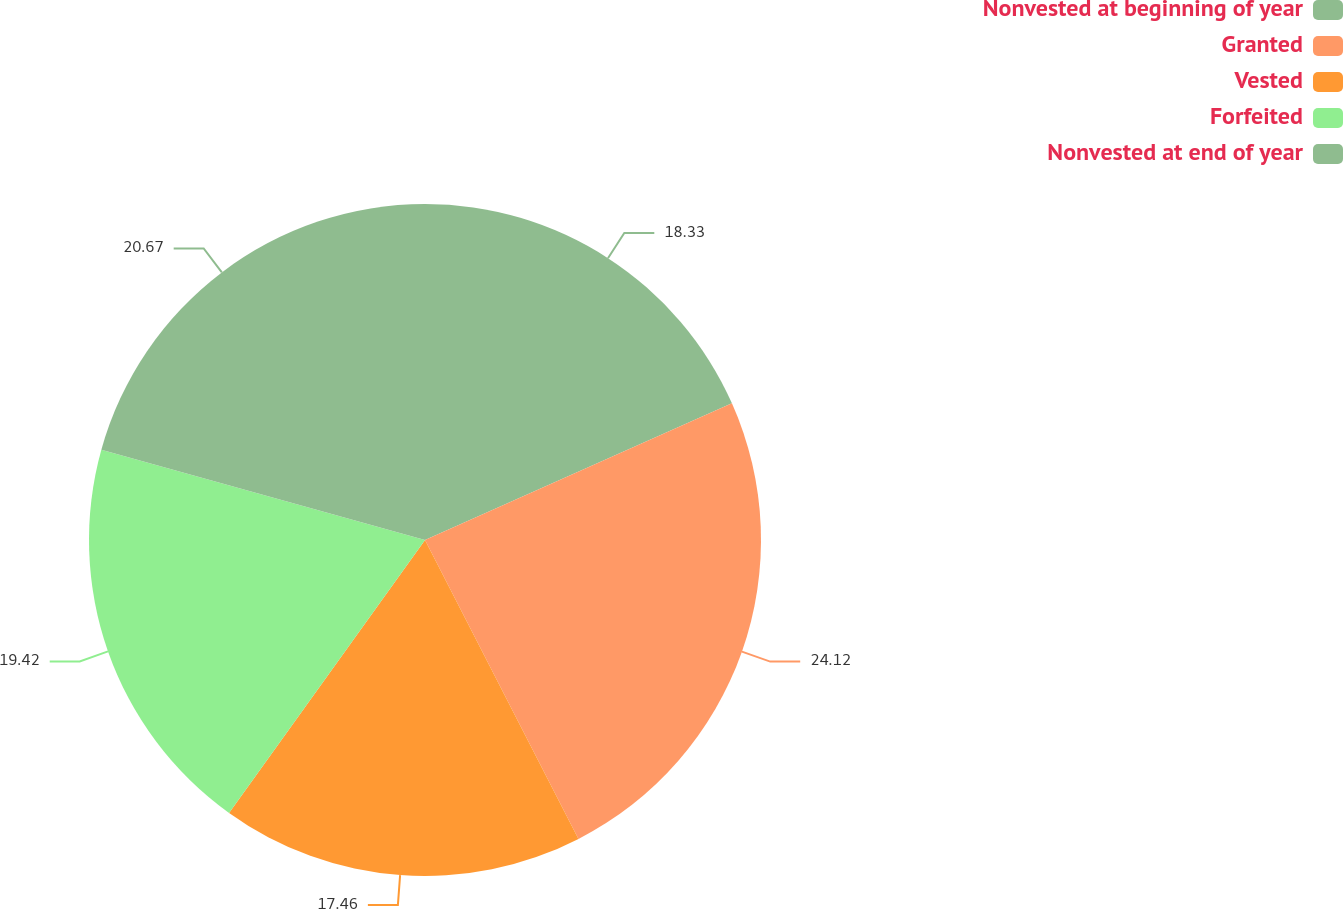Convert chart. <chart><loc_0><loc_0><loc_500><loc_500><pie_chart><fcel>Nonvested at beginning of year<fcel>Granted<fcel>Vested<fcel>Forfeited<fcel>Nonvested at end of year<nl><fcel>18.33%<fcel>24.12%<fcel>17.46%<fcel>19.42%<fcel>20.67%<nl></chart> 